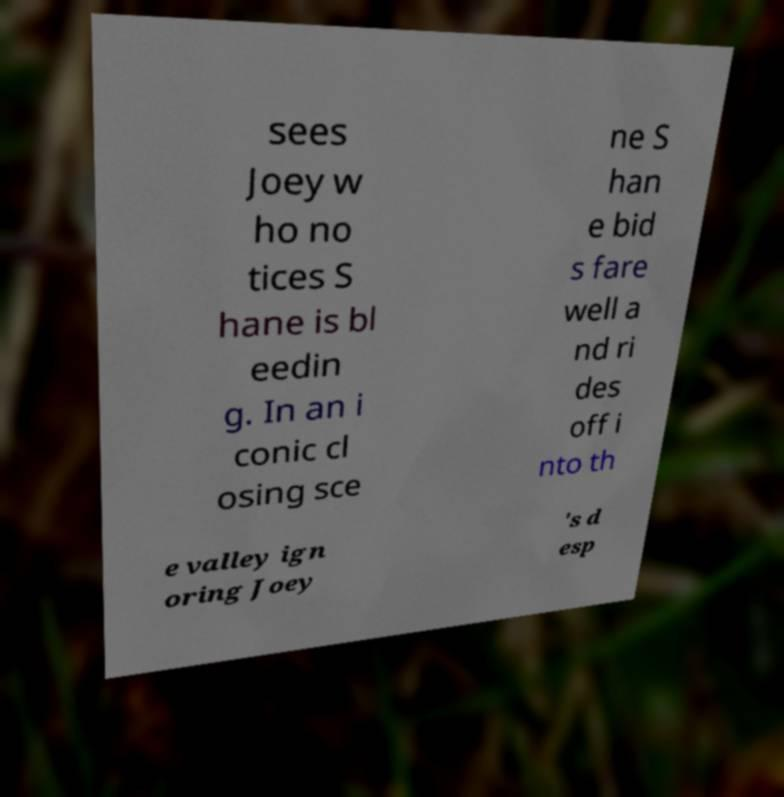I need the written content from this picture converted into text. Can you do that? sees Joey w ho no tices S hane is bl eedin g. In an i conic cl osing sce ne S han e bid s fare well a nd ri des off i nto th e valley ign oring Joey 's d esp 